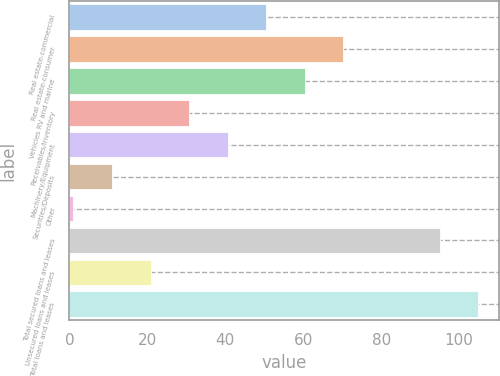<chart> <loc_0><loc_0><loc_500><loc_500><bar_chart><fcel>Real estate-commercial<fcel>Real estate-consumer<fcel>Vehicles RV and marine<fcel>Receivables/Inventory<fcel>Machinery/Equipment<fcel>Securities/Deposits<fcel>Other<fcel>Total secured loans and leases<fcel>Unsecured loans and leases<fcel>Total loans and leases<nl><fcel>50.5<fcel>70.3<fcel>60.4<fcel>30.7<fcel>40.6<fcel>10.9<fcel>1<fcel>95<fcel>20.8<fcel>104.9<nl></chart> 